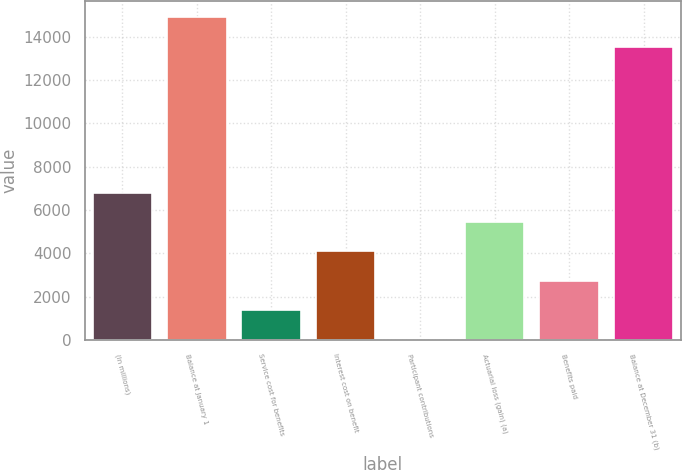Convert chart. <chart><loc_0><loc_0><loc_500><loc_500><bar_chart><fcel>(In millions)<fcel>Balance at January 1<fcel>Service cost for benefits<fcel>Interest cost on benefit<fcel>Participant contributions<fcel>Actuarial loss (gain) (a)<fcel>Benefits paid<fcel>Balance at December 31 (b)<nl><fcel>6799<fcel>14892<fcel>1371<fcel>4085<fcel>14<fcel>5442<fcel>2728<fcel>13535<nl></chart> 